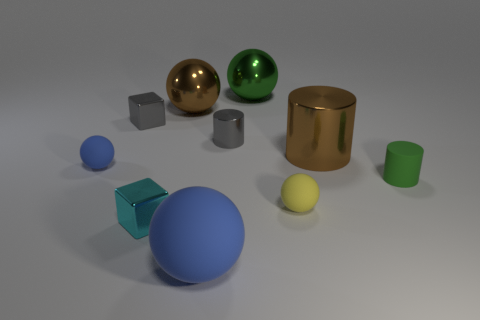Can you describe the lighting used in the scene? The lighting in the image appears to be diffused, coming from above. It casts soft shadows beneath each object, enhancing their three-dimensionality without creating harsh contrasts. 